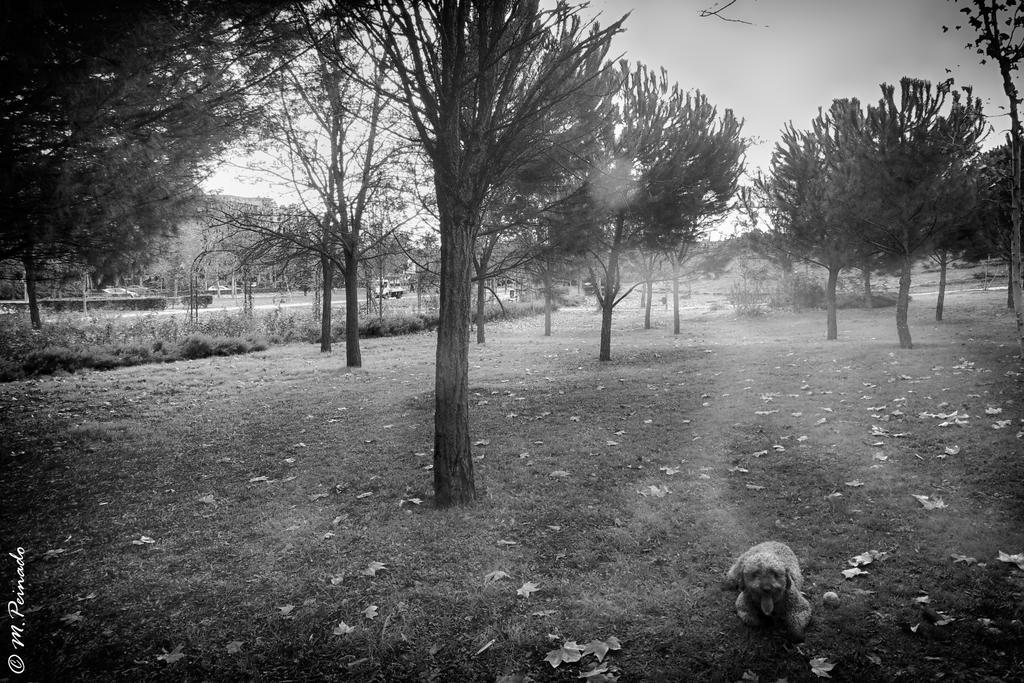What type of animal is featured in the black and white picture in the image? There is a black and white picture of a dog in the image. What type of vegetation can be seen in the image? There are trees and grass in the image. What else can be found on the ground in the image? Dry leaves are present in the image. What is visible in the background of the image? The sky is visible in the image. Is there any text or marking on the image? Yes, there is a watermark on the bottom left of the image. Where is the boy playing in the image? There is no boy present in the image; it features a black and white picture of a dog. What type of railway can be seen in the image? There is no railway present in the image. 